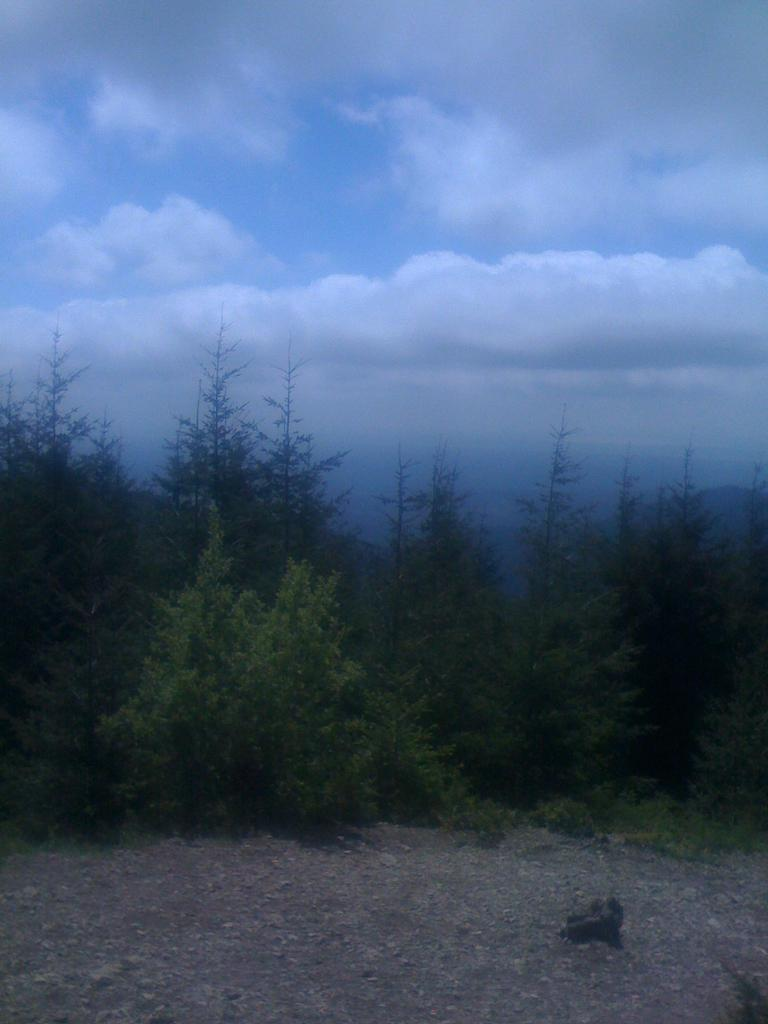What type of vegetation can be seen in the image? There are trees in the image. What is visible at the bottom of the image? There is ground visible at the bottom of the image. Can you describe the object in the image? Unfortunately, the facts provided do not give enough information to describe the object in the image. What is visible in the sky at the top of the image? There are clouds in the sky at the top of the image. What is the name of the person standing next to the cannon in the image? There is no person or cannon present in the image. How many bits are visible in the image? There are no bits present in the image. 